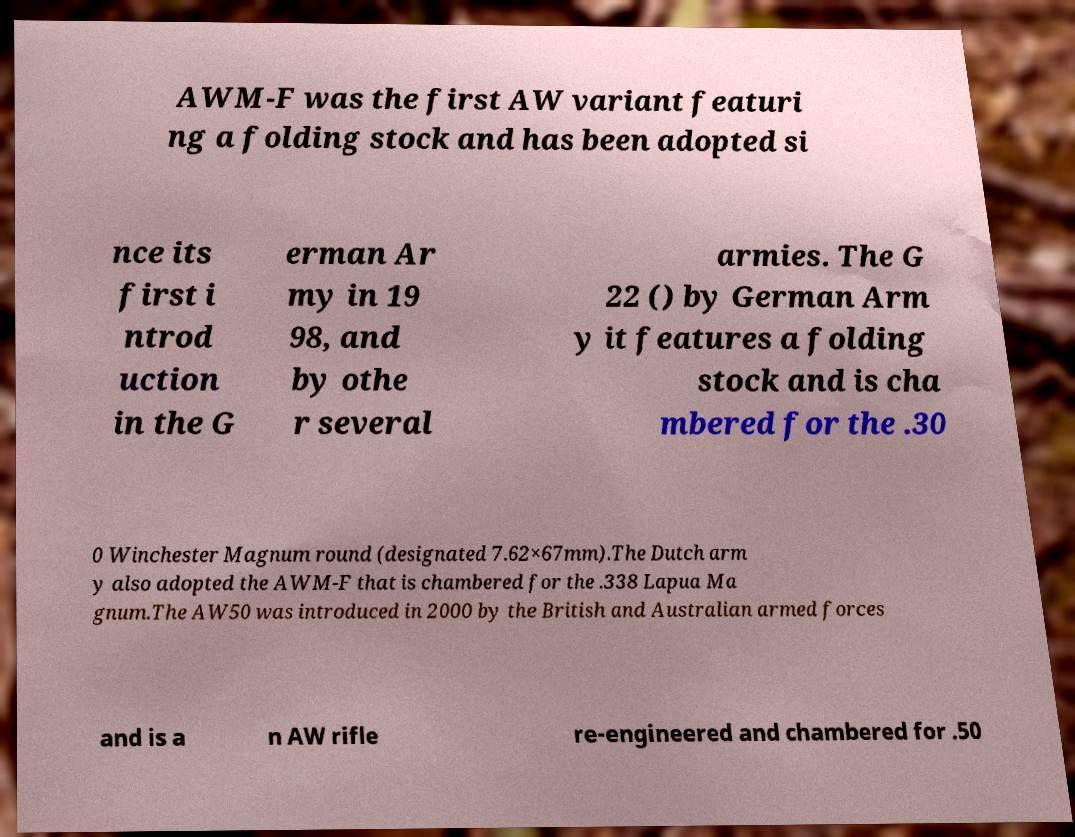For documentation purposes, I need the text within this image transcribed. Could you provide that? AWM-F was the first AW variant featuri ng a folding stock and has been adopted si nce its first i ntrod uction in the G erman Ar my in 19 98, and by othe r several armies. The G 22 () by German Arm y it features a folding stock and is cha mbered for the .30 0 Winchester Magnum round (designated 7.62×67mm).The Dutch arm y also adopted the AWM-F that is chambered for the .338 Lapua Ma gnum.The AW50 was introduced in 2000 by the British and Australian armed forces and is a n AW rifle re-engineered and chambered for .50 